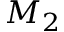<formula> <loc_0><loc_0><loc_500><loc_500>M _ { 2 }</formula> 